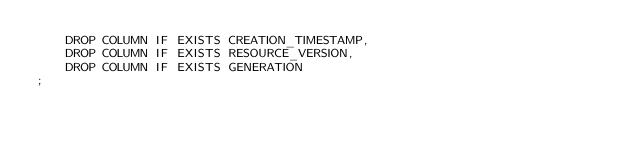Convert code to text. <code><loc_0><loc_0><loc_500><loc_500><_SQL_>    DROP COLUMN IF EXISTS CREATION_TIMESTAMP,
    DROP COLUMN IF EXISTS RESOURCE_VERSION,
    DROP COLUMN IF EXISTS GENERATION
;
</code> 